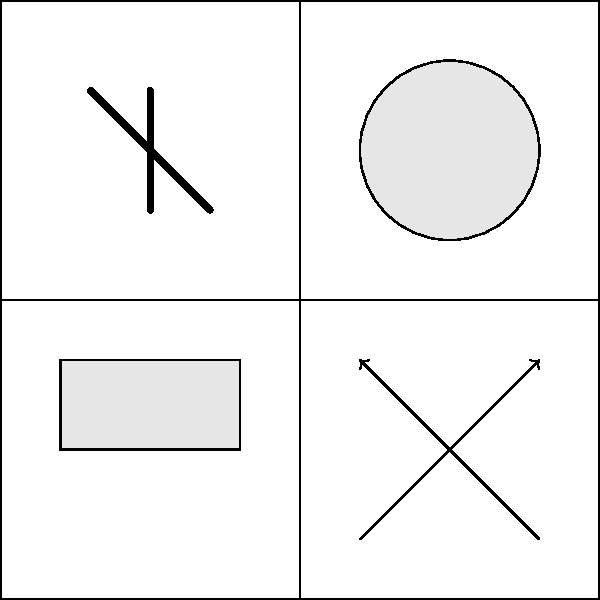Analisando a colagem de obras de arte digital apresentada, qual motivo visual comum na criptoarte é mais predominante e reflete a influência das criptomoedas no mercado de arte contemporânea? Para responder a esta questão, devemos analisar os elementos visuais presentes na colagem:

1. No quadrante superior esquerdo, vemos linhas que se assemelham ao símbolo do Ethereum (ETH).
2. No quadrante superior direito, há um círculo que pode representar uma moeda ou token.
3. No quadrante inferior esquerdo, temos um retângulo que pode simbolizar um bloco na blockchain.
4. No quadrante inferior direito, observamos setas bidirecionais, indicando transações ou trocas.

Analisando esses elementos:
- O símbolo do Ethereum é uma referência direta a uma criptomoeda específica.
- O círculo/moeda é uma representação genérica de criptomoedas.
- O retângulo/bloco reflete a tecnologia blockchain subjacente às criptomoedas.
- As setas indicam a natureza transacional das criptomoedas.

O motivo mais predominante e que melhor reflete a influência das criptomoedas na arte contemporânea é a representação simbólica de criptomoedas específicas, como o Ethereum. Este símbolo é o mais reconhecível e diretamente ligado ao mundo cripto, demonstrando como as criptomoedas estão sendo incorporadas na linguagem visual da arte digital contemporânea.
Answer: Símbolos de criptomoedas específicas (ex: Ethereum) 